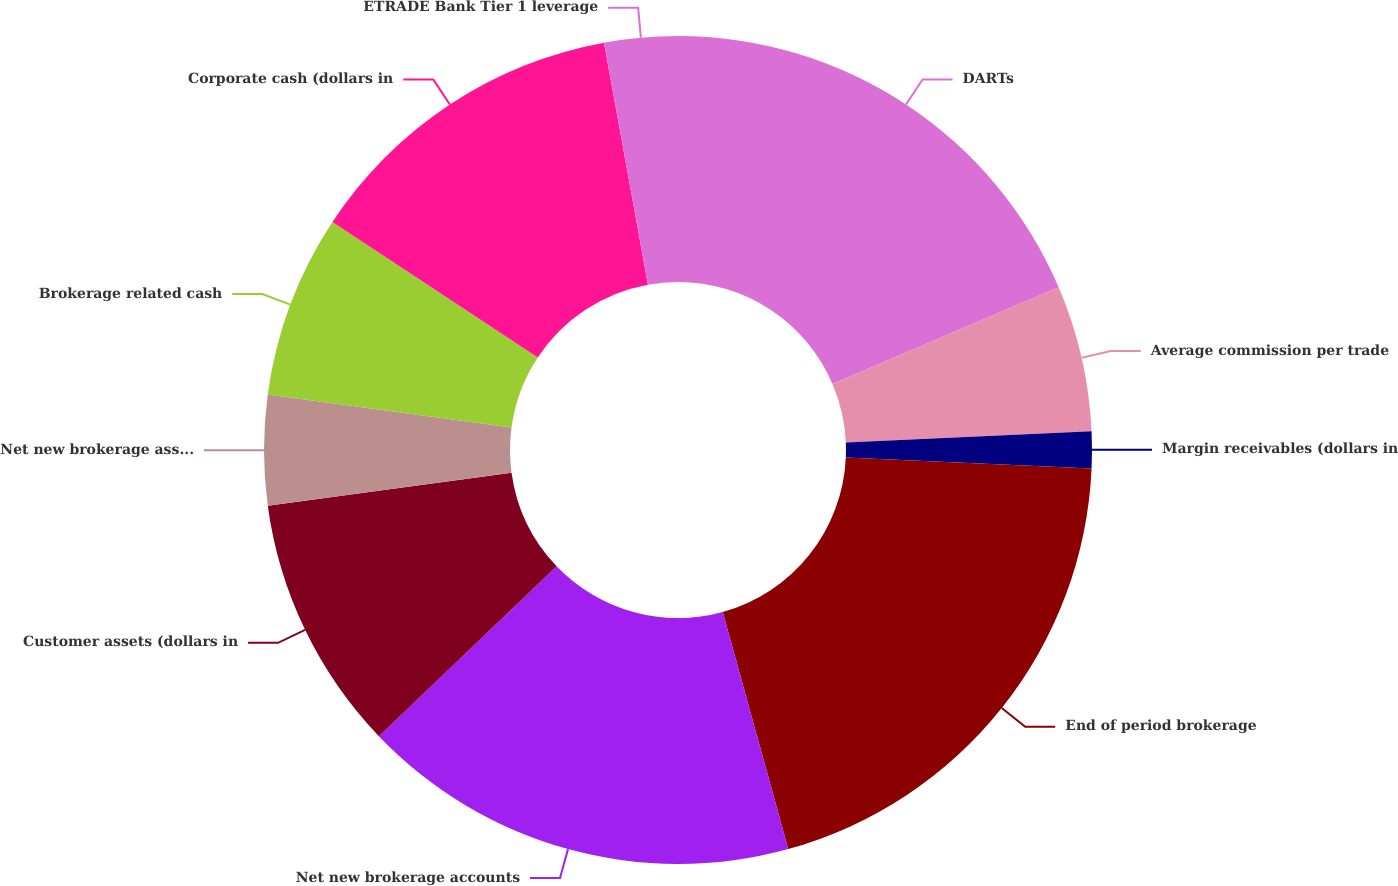Convert chart. <chart><loc_0><loc_0><loc_500><loc_500><pie_chart><fcel>DARTs<fcel>Average commission per trade<fcel>Margin receivables (dollars in<fcel>End of period brokerage<fcel>Net new brokerage accounts<fcel>Customer assets (dollars in<fcel>Net new brokerage assets<fcel>Brokerage related cash<fcel>Corporate cash (dollars in<fcel>ETRADE Bank Tier 1 leverage<nl><fcel>18.57%<fcel>5.71%<fcel>1.43%<fcel>20.0%<fcel>17.14%<fcel>10.0%<fcel>4.29%<fcel>7.14%<fcel>12.86%<fcel>2.86%<nl></chart> 